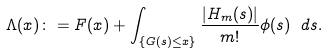Convert formula to latex. <formula><loc_0><loc_0><loc_500><loc_500>\Lambda ( x ) \colon = F ( x ) + \int _ { \{ G ( s ) \leq x \} } \frac { | H _ { m } ( s ) | } { m ! } \phi ( s ) \ d s .</formula> 